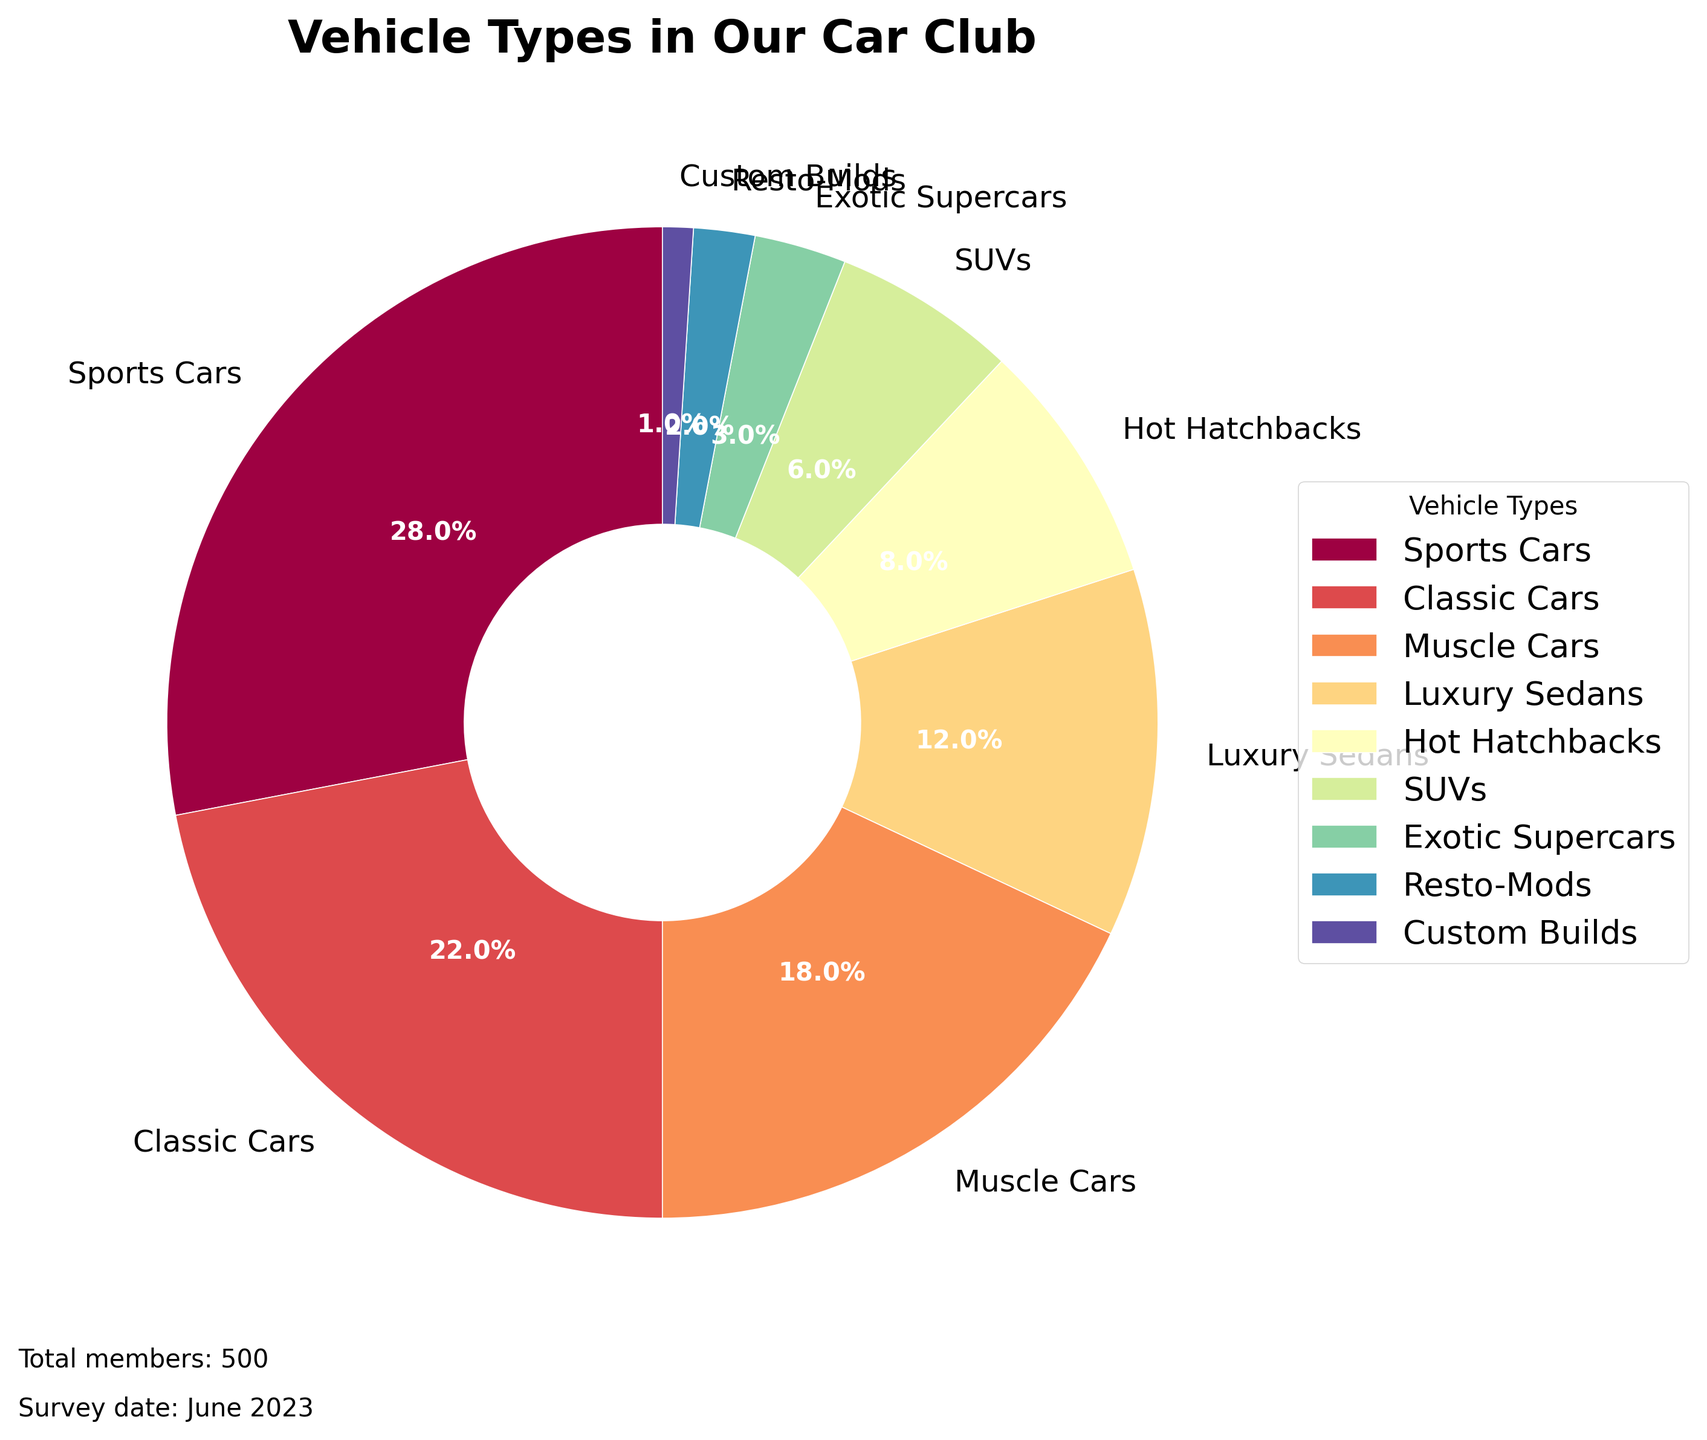What percentage of the car club members owns Muscle Cars? To find the percentage of members owning Muscle Cars, refer to the pie chart's labels and corresponding percentages section. Muscle Cars are shown with a label indicating 18%.
Answer: 18% Which vehicle type has the smallest percentage of ownership among club members? Look through the labels and their associated percentages around the pie chart. The type with the smallest percentage is Custom Builds, which is 1%.
Answer: Custom Builds Are there more Luxury Sedans or SUVs owned by members in the club? To compare, check the percentages of both Luxury Sedans and SUVs in the pie chart. Luxury Sedans have 12% ownership while SUVs have 6%. Since 12% is greater than 6%, there are more Luxury Sedans.
Answer: Luxury Sedans What is the total percentage of members owning either Hot Hatchbacks or Classic Cars? Add the percentages of Hot Hatchbacks and Classic Cars from the pie chart. Hot Hatchbacks are 8% and Classic Cars are 22%, so the total is 8% + 22%, which equals 30%.
Answer: 30% How much higher is the percentage of members owning Sports Cars compared to Exotic Supercars? Find and subtract the percentages of Exotic Supercars from Sports Cars. Sports Cars have 28% ownership and Exotic Supercars have 3%. The difference is 28% - 3% = 25%.
Answer: 25% Which vehicle type is owned by exactly twice the percentage of members compared to SUVs? To find the type with twice the SUV percentage, multiply the SUV percentage by 2. SUVs have 6%, so 2 * 6 = 12%. The vehicle type with 12% ownership is Luxury Sedans.
Answer: Luxury Sedans What is the combined percentage of ownership for vehicles that are not Sports Cars or Classic Cars? Subtract the sum of Sports Cars and Classic Cars from 100%. Sports Cars have 28% and Classic Cars have 22%, so their combined percentage is 28% + 22% = 50%. The remaining is 100% - 50% = 50%.
Answer: 50% Which vehicle type is visually represented with the largest wedge in the pie chart? Identify the vehicle type with the largest percentage, as a larger percentage means a larger wedge. Sports Cars have the highest percentage at 28%, making it the largest wedge.
Answer: Sports Cars 